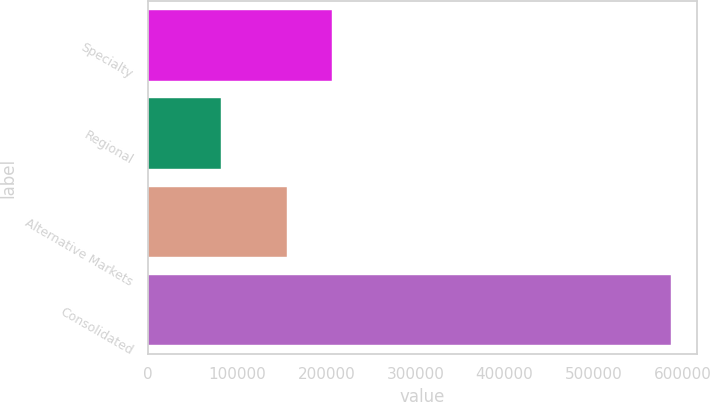Convert chart to OTSL. <chart><loc_0><loc_0><loc_500><loc_500><bar_chart><fcel>Specialty<fcel>Regional<fcel>Alternative Markets<fcel>Consolidated<nl><fcel>206667<fcel>81635<fcel>156154<fcel>586763<nl></chart> 